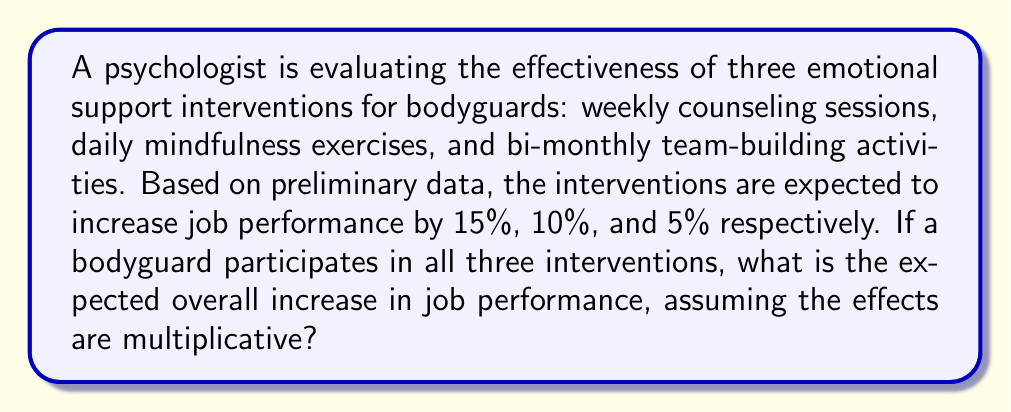Help me with this question. Let's approach this step-by-step:

1) First, we need to understand what multiplicative effects mean. When effects are multiplicative, we multiply the factors rather than add them.

2) We're given the following increases:
   - Weekly counseling sessions: 15% increase (1.15 factor)
   - Daily mindfulness exercises: 10% increase (1.10 factor)
   - Bi-monthly team-building activities: 5% increase (1.05 factor)

3) To calculate the overall effect, we multiply these factors:

   $$ \text{Overall factor} = 1.15 \times 1.10 \times 1.05 $$

4) Let's compute this:

   $$ \text{Overall factor} = 1.15 \times 1.10 \times 1.05 = 1.32825 $$

5) This factor represents the final performance level compared to the initial level. To find the percentage increase, we subtract 1 and multiply by 100:

   $$ \text{Percentage increase} = (1.32825 - 1) \times 100\% = 0.32825 \times 100\% = 32.825\% $$

Therefore, the expected overall increase in job performance is approximately 32.825%.
Answer: 32.825% 